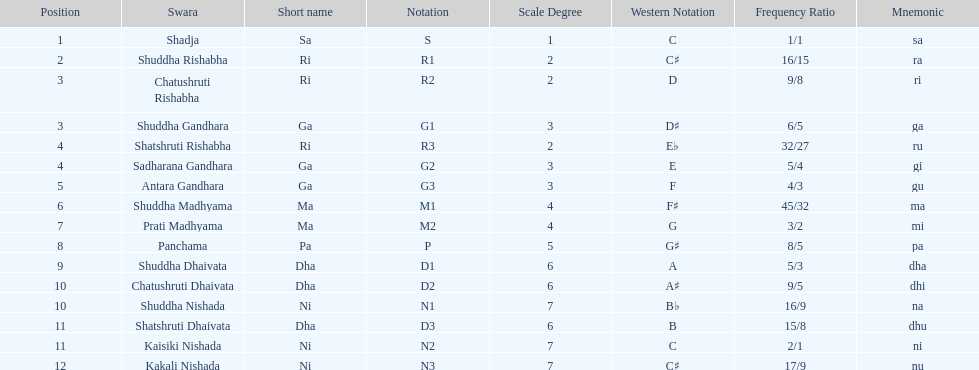What is the name of the swara that holds the first position? Shadja. 